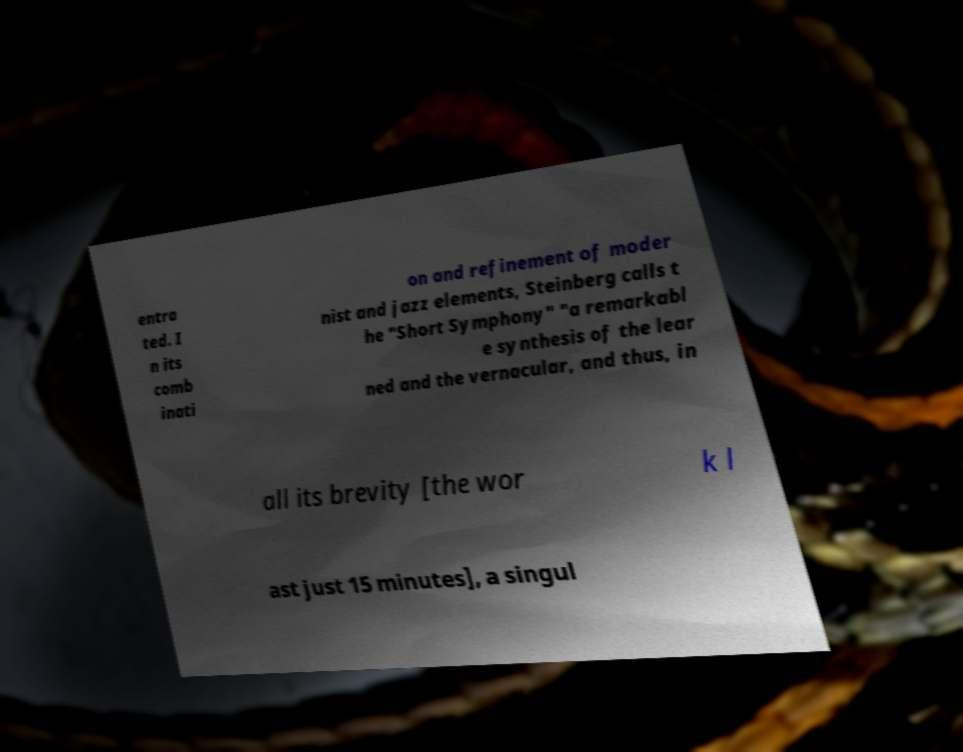What messages or text are displayed in this image? I need them in a readable, typed format. entra ted. I n its comb inati on and refinement of moder nist and jazz elements, Steinberg calls t he "Short Symphony" "a remarkabl e synthesis of the lear ned and the vernacular, and thus, in all its brevity [the wor k l ast just 15 minutes], a singul 